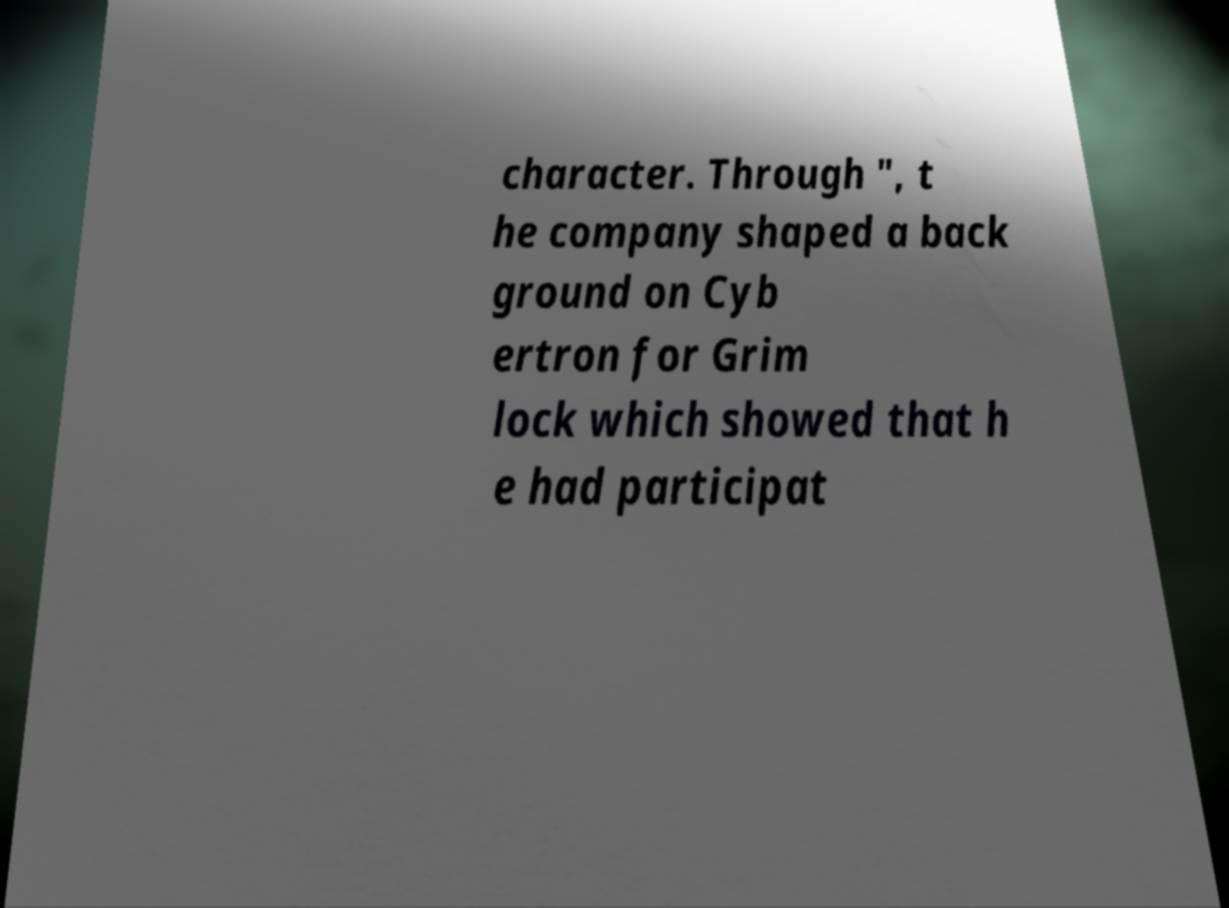Please read and relay the text visible in this image. What does it say? character. Through ", t he company shaped a back ground on Cyb ertron for Grim lock which showed that h e had participat 